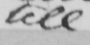Can you read and transcribe this handwriting? tell 